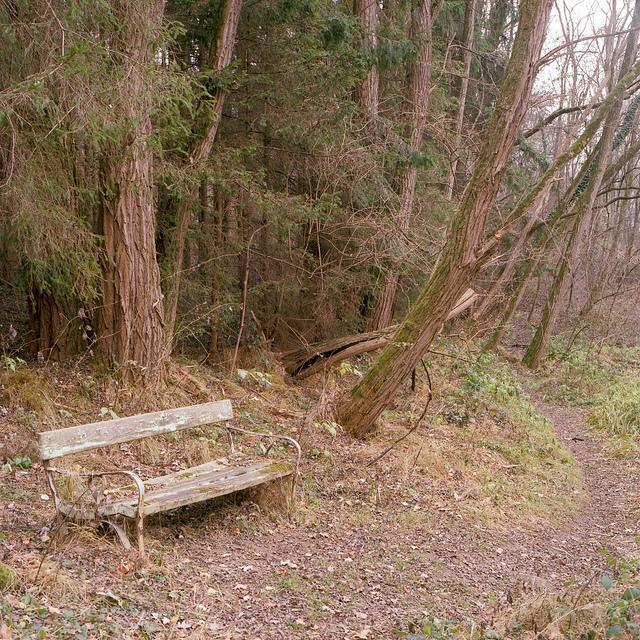How many people holds a white bag in a kitchen?
Give a very brief answer. 0. 